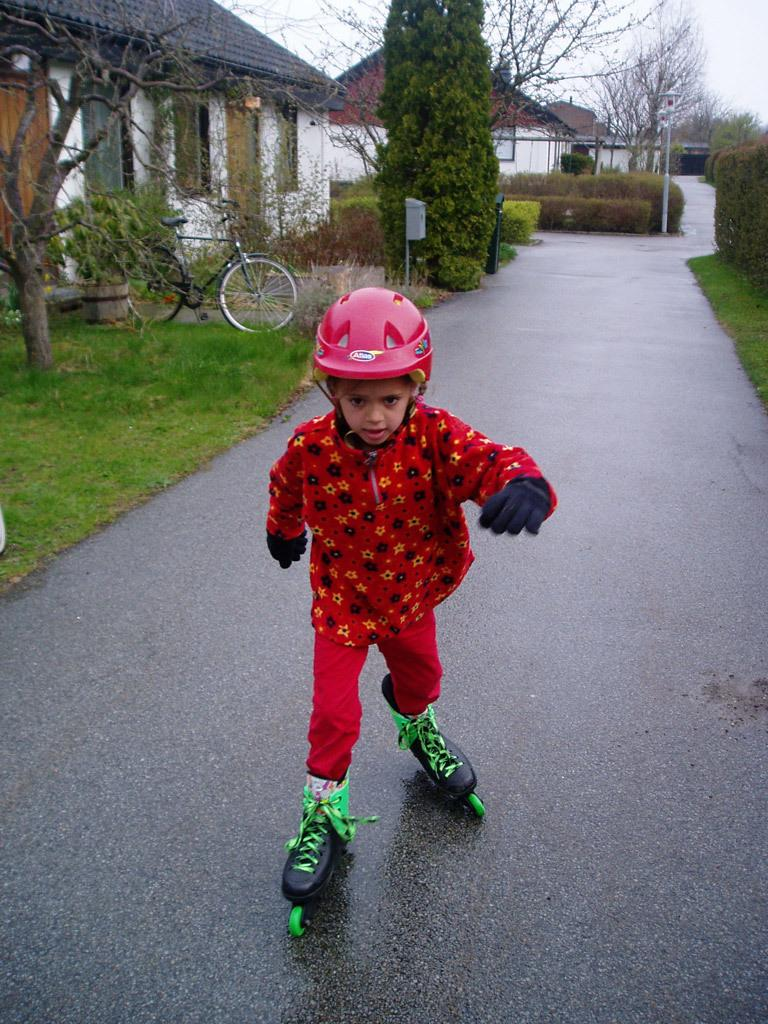What is the main subject of the image? The main subject of the image is a kid. What is the kid doing in the image? The kid is skating on the road. What can be seen beside the road in the image? There is a building beside the road. What type of vegetation is present near the road? Trees are present near the road. What other mode of transportation is visible in the image? A bicycle is visible in the image. What type of ground surface is present in the image? Grass is present in the image. What type of square can be seen in the image? There is no square present in the image. Is there a tent visible in the image? No, there is no tent present in the image. 